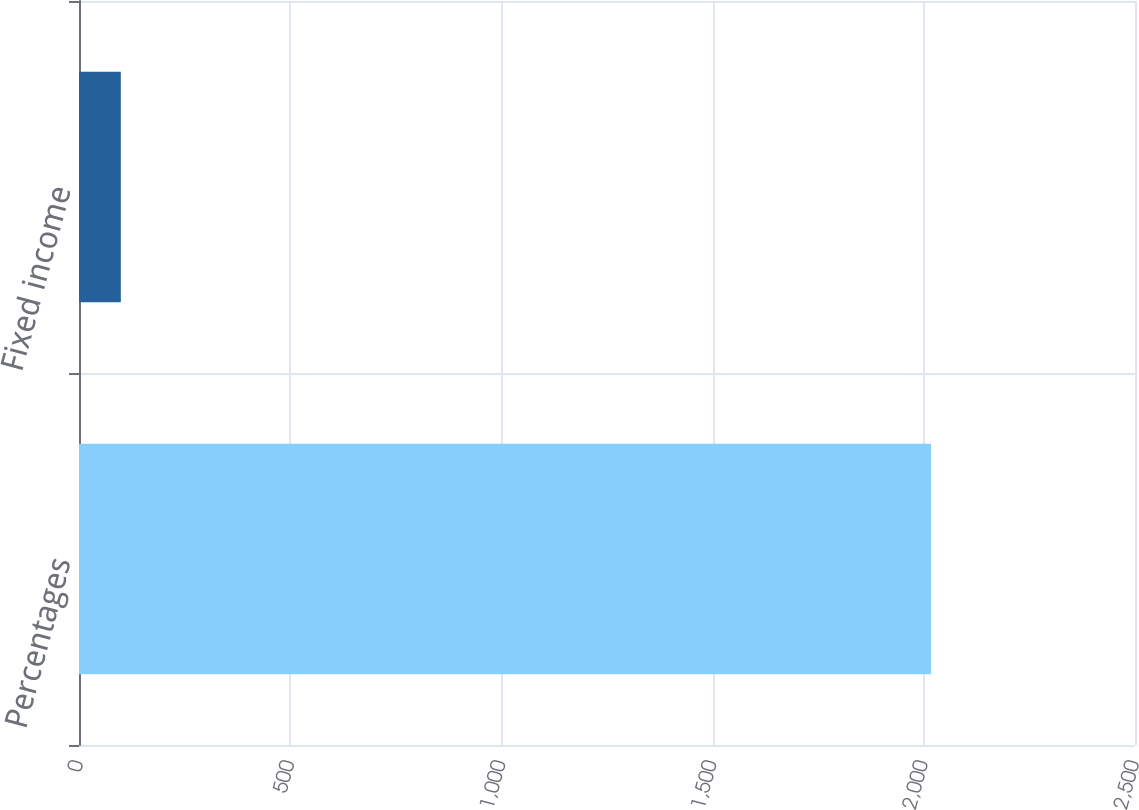<chart> <loc_0><loc_0><loc_500><loc_500><bar_chart><fcel>Percentages<fcel>Fixed income<nl><fcel>2017<fcel>99<nl></chart> 